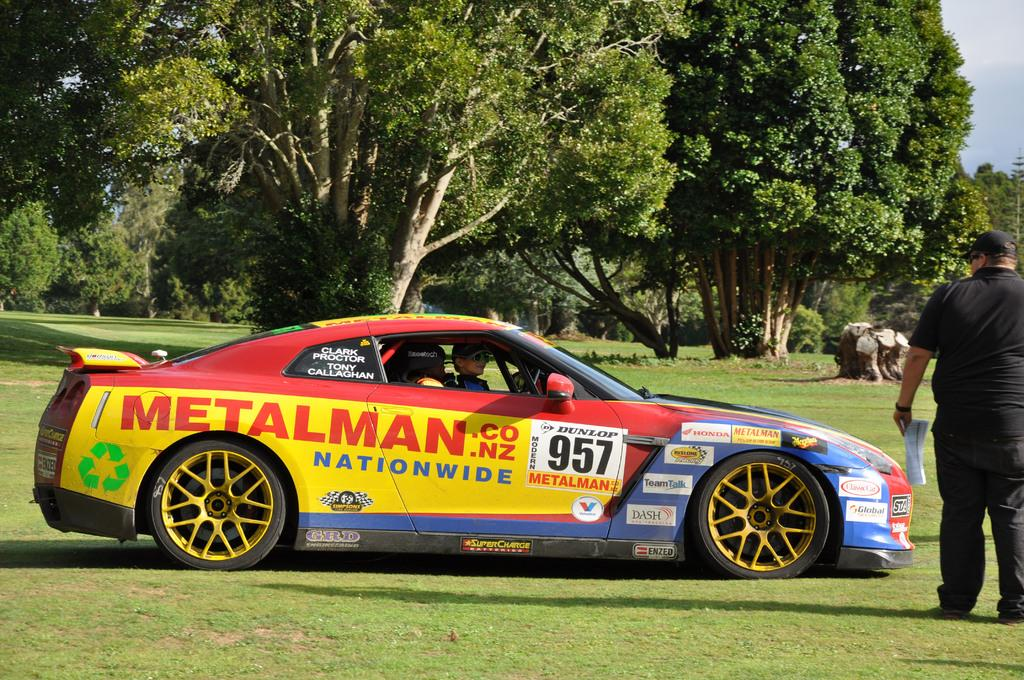What is the main subject of the image? The main subject of the image is persons in a car in the center of the image. Can you describe the person on the right side of the image? There is a person standing on the grass on the right side of the image. What can be seen in the background of the image? There are trees, grass, and the sky visible in the background of the image. What type of paste is being used by the person in the car? There is no paste present in the image; it features persons in a car and a person standing on the grass. 